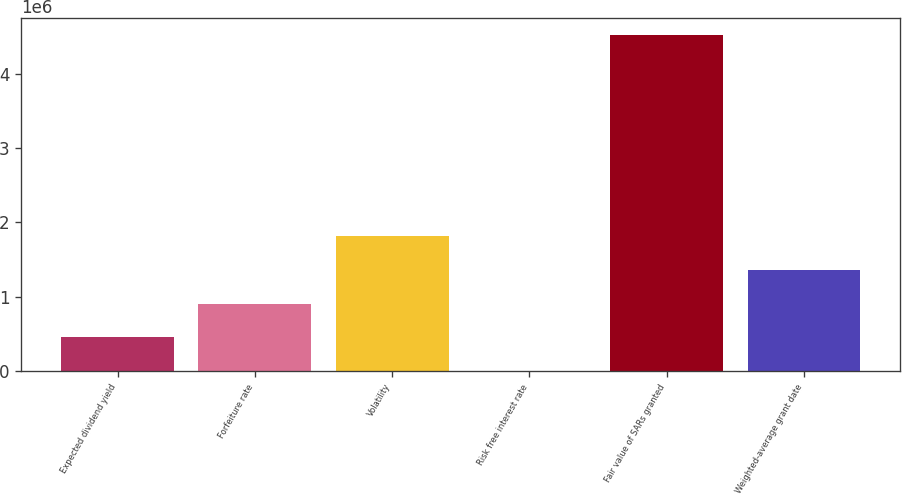Convert chart to OTSL. <chart><loc_0><loc_0><loc_500><loc_500><bar_chart><fcel>Expected dividend yield<fcel>Forfeiture rate<fcel>Volatility<fcel>Risk free interest rate<fcel>Fair value of SARs granted<fcel>Weighted-average grant date<nl><fcel>452801<fcel>905601<fcel>1.8112e+06<fcel>0.82<fcel>4.528e+06<fcel>1.3584e+06<nl></chart> 